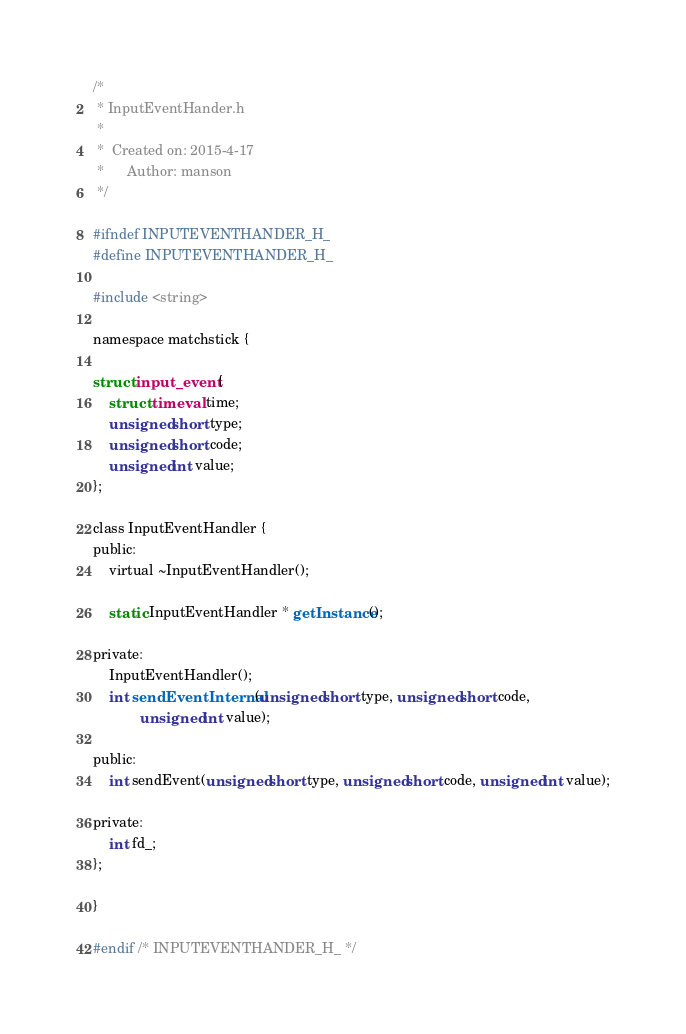Convert code to text. <code><loc_0><loc_0><loc_500><loc_500><_C_>/*
 * InputEventHander.h
 *
 *  Created on: 2015-4-17
 *      Author: manson
 */

#ifndef INPUTEVENTHANDER_H_
#define INPUTEVENTHANDER_H_

#include <string>

namespace matchstick {

struct input_event {
	struct timeval time;
	unsigned short type;
	unsigned short code;
	unsigned int value;
};

class InputEventHandler {
public:
	virtual ~InputEventHandler();

	static InputEventHandler * getInstance();

private:
	InputEventHandler();
	int sendEventInternal(unsigned short type, unsigned short code,
			unsigned int value);

public:
	int sendEvent(unsigned short type, unsigned short code, unsigned int value);

private:
	int fd_;
};

}

#endif /* INPUTEVENTHANDER_H_ */
</code> 